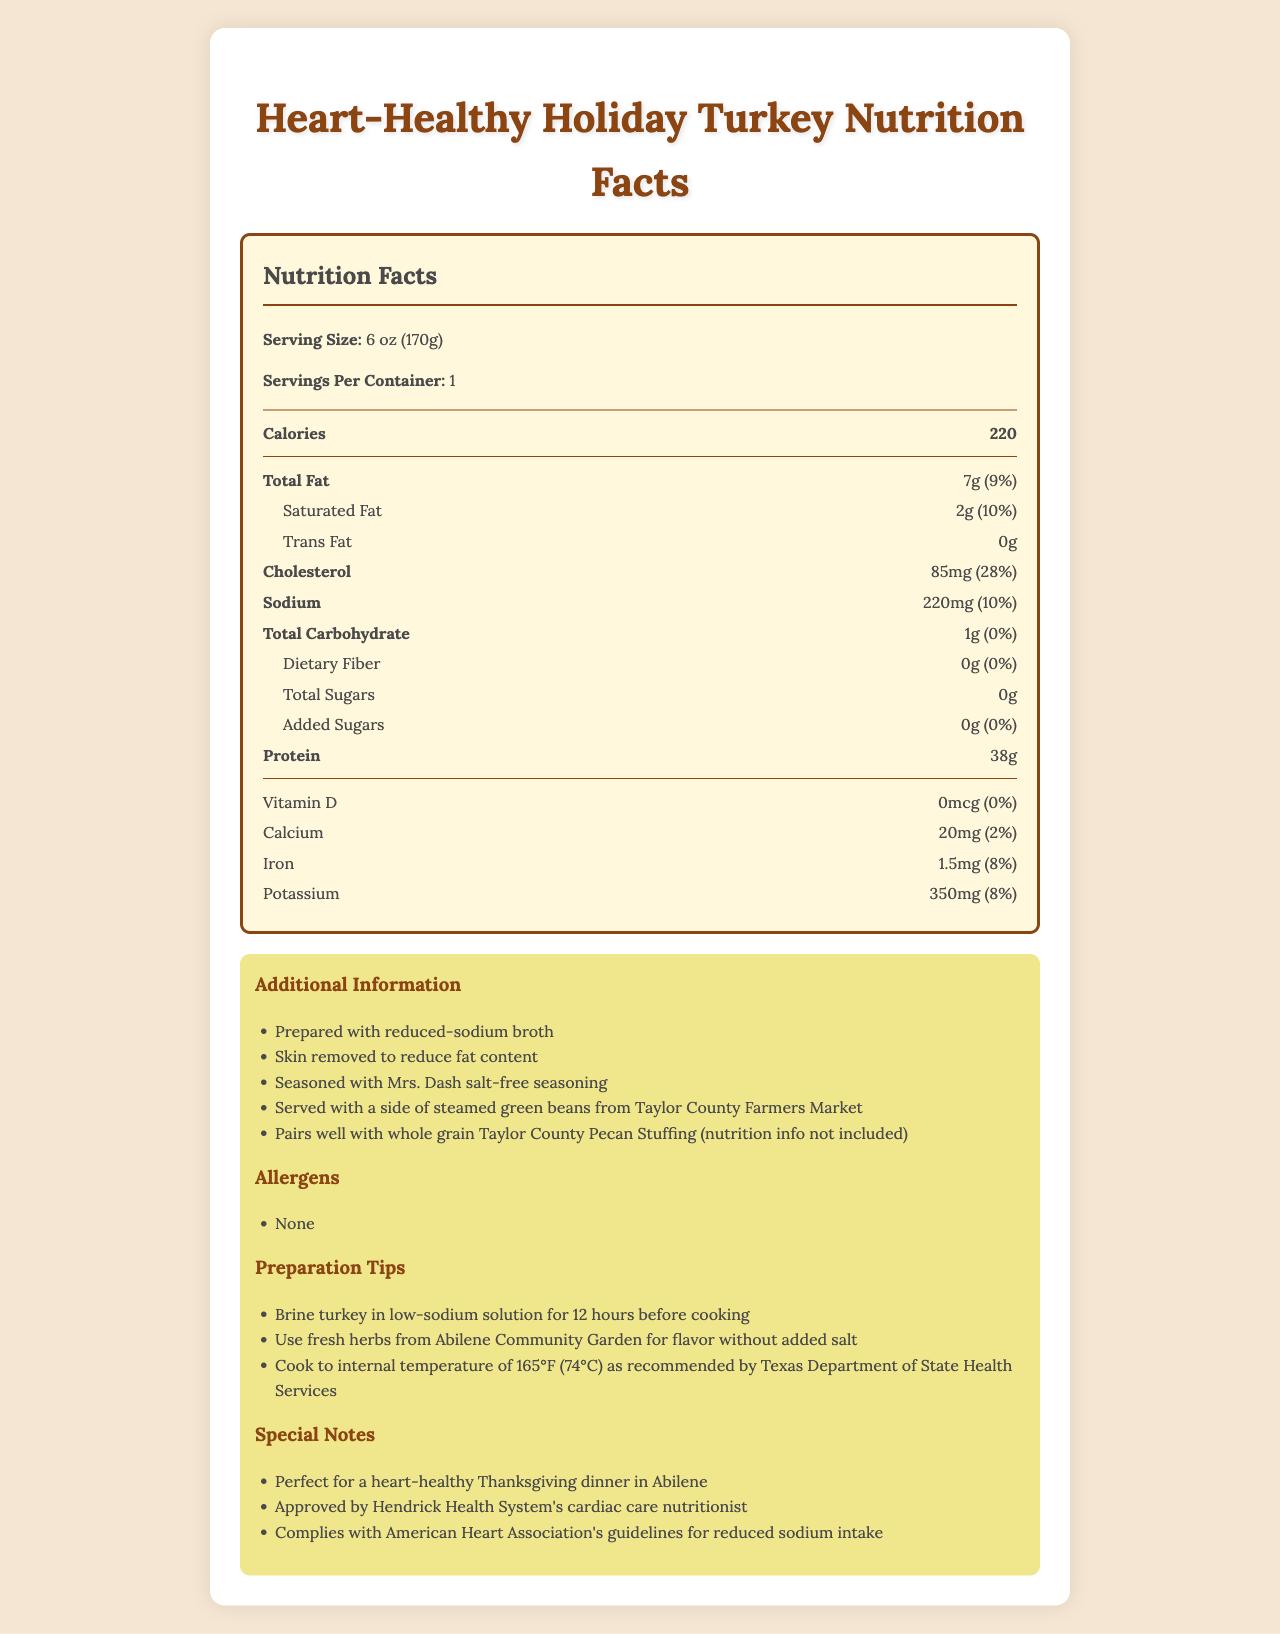what is the serving size of the turkey? The serving size information is listed at the top of the nutrition label as "Serving Size: 6 oz (170g)".
Answer: 6 oz (170g) how many calories are in a serving? The calorie count is listed in bold text on the nutrition label as "Calories 220".
Answer: 220 how much total fat does one serving contain? The total fat content is indicated on the nutrition label as "Total Fat 7g (9%)".
Answer: 7g what is the daily value percentage for saturated fat? The daily value percentage for saturated fat is shown in parentheses next to the saturated fat content as "Saturated Fat 2g (10%)".
Answer: 10% does the turkey contain any trans fat? The nutrition label specifically lists the trans fat content as "Trans Fat 0g", meaning there is no trans fat.
Answer: No how much protein is present in one serving? The amount of protein per serving is displayed on the nutrition label as "Protein 38g".
Answer: 38g how should the turkey be prepared for optimal heart health? A. Brine in high-sodium solution B. Cook at 140°F C. Use fresh herbs for flavor and cook to 165°F The preparation tips suggest "Brine turkey in low-sodium solution for 12 hours before cooking" and "Use fresh herbs for flavor" along with "Cook to internal temperature of 165°F (74°C)".
Answer: C what percentage of the daily value of potassium does one serving provide? A. 8% B. 10% C. 20% The nutrition label lists the potassium content as "Potassium 350mg (8%)", indicating it provides 8% of the daily value.
Answer: A is this turkey suitable for someone with heart concerns? The document specifies that the turkey is "perfect for a heart-healthy Thanksgiving dinner" and is "approved by Hendrick Health System's cardiac care nutritionist".
Answer: Yes what are some preparations tips for the turkey? The preparation tips section includes "Brine turkey in low-sodium solution for 12 hours", "Use fresh herbs from Abilene Community Garden for flavor without added salt", and "Cook to internal temperature of 165°F (74°C)".
Answer: Brine in low-sodium solution, use fresh herbs, cook to 165°F does this turkey contain any allergens? The document clearly states in the allergens section that there are "None".
Answer: No how much calcium does one serving of the turkey provide? The nutrition label shows the calcium content as "Calcium 20mg (2%)".
Answer: 20mg what special notes are mentioned about this turkey? The special notes section includes details like "Perfect for a heart-healthy Thanksgiving dinner", "Approved by Hendrick Health System's cardiac care nutritionist", and compliance with the "American Heart Association's guidelines for reduced sodium intake".
Answer: Heart-healthy, approved by Hendrick Health System, follows AHA guidelines what is the source of the seasoning used on the turkey? The additional information section indicates that the turkey is "seasoned with Mrs. Dash salt-free seasoning".
Answer: Mrs. Dash salt-free seasoning what is the main idea of this document? The document provides detailed nutrition information, preparation tips, and special notes aimed at promoting a heart-healthy turkey dinner.
Answer: Nutrition facts and health benefits of a heart-healthy turkey dinner what are the potassium levels in the turkey compared to similar meals? The document does not provide any information or comparison regarding the potassium levels of similar meals.
Answer: Cannot be determined 